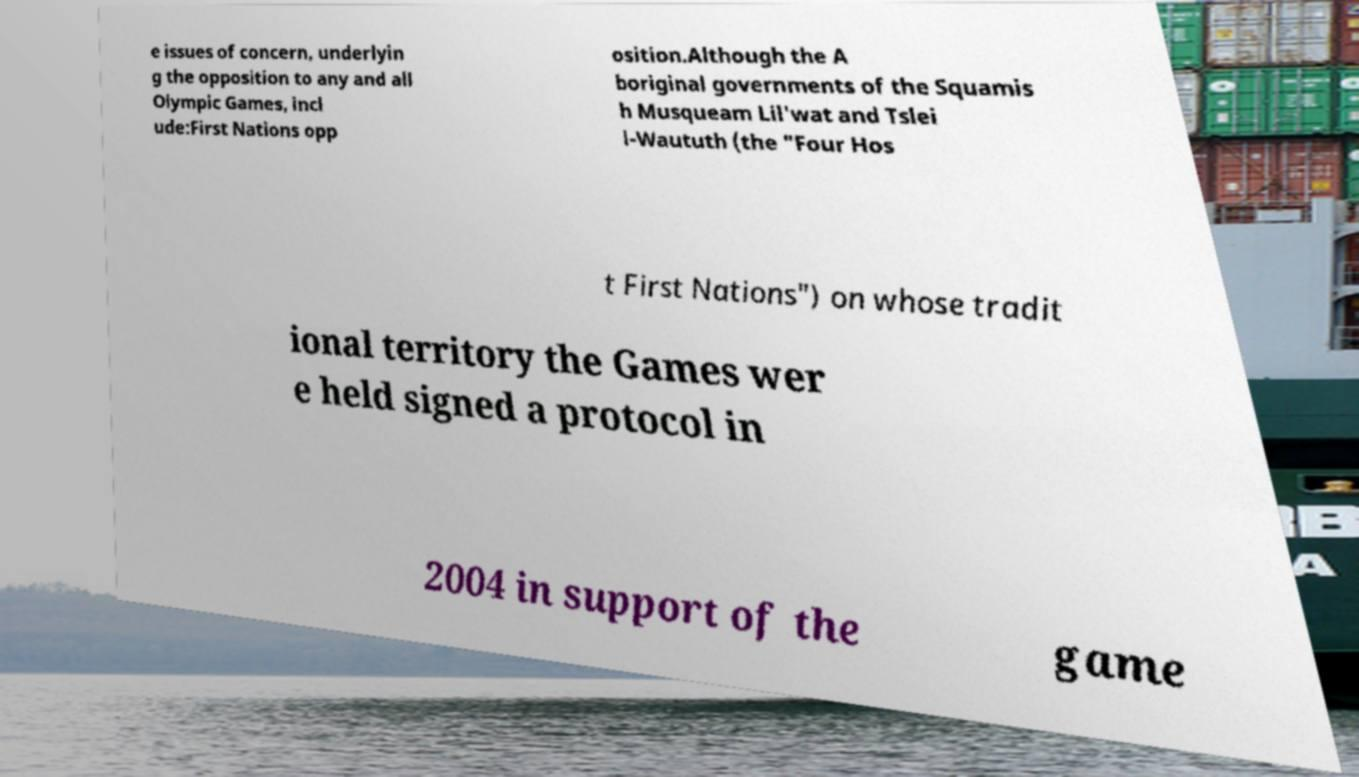Could you assist in decoding the text presented in this image and type it out clearly? e issues of concern, underlyin g the opposition to any and all Olympic Games, incl ude:First Nations opp osition.Although the A boriginal governments of the Squamis h Musqueam Lil'wat and Tslei l-Waututh (the "Four Hos t First Nations") on whose tradit ional territory the Games wer e held signed a protocol in 2004 in support of the game 